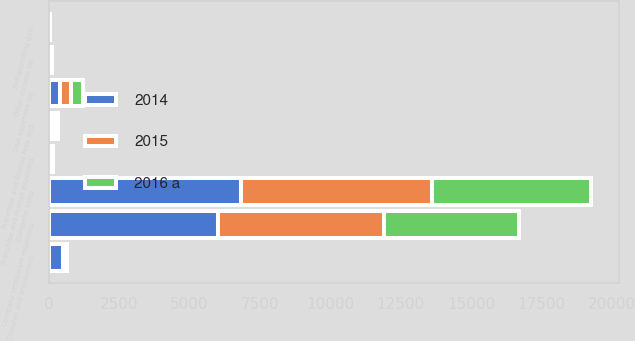Convert chart to OTSL. <chart><loc_0><loc_0><loc_500><loc_500><stacked_bar_chart><ecel><fcel>Company sales<fcel>Franchise and license fees and<fcel>Company restaurant expenses<fcel>G&A expenses (b)<fcel>Franchise and license expenses<fcel>Closures and impairment<fcel>Refranchising gain<fcel>Other income (d)<nl><fcel>2016 a<fcel>5667<fcel>109<fcel>4766<fcel>406<fcel>45<fcel>57<fcel>12<fcel>49<nl><fcel>2015<fcel>6789<fcel>120<fcel>5913<fcel>405<fcel>48<fcel>64<fcel>13<fcel>27<nl><fcel>2014<fcel>6821<fcel>113<fcel>6011<fcel>391<fcel>44<fcel>517<fcel>17<fcel>52<nl></chart> 